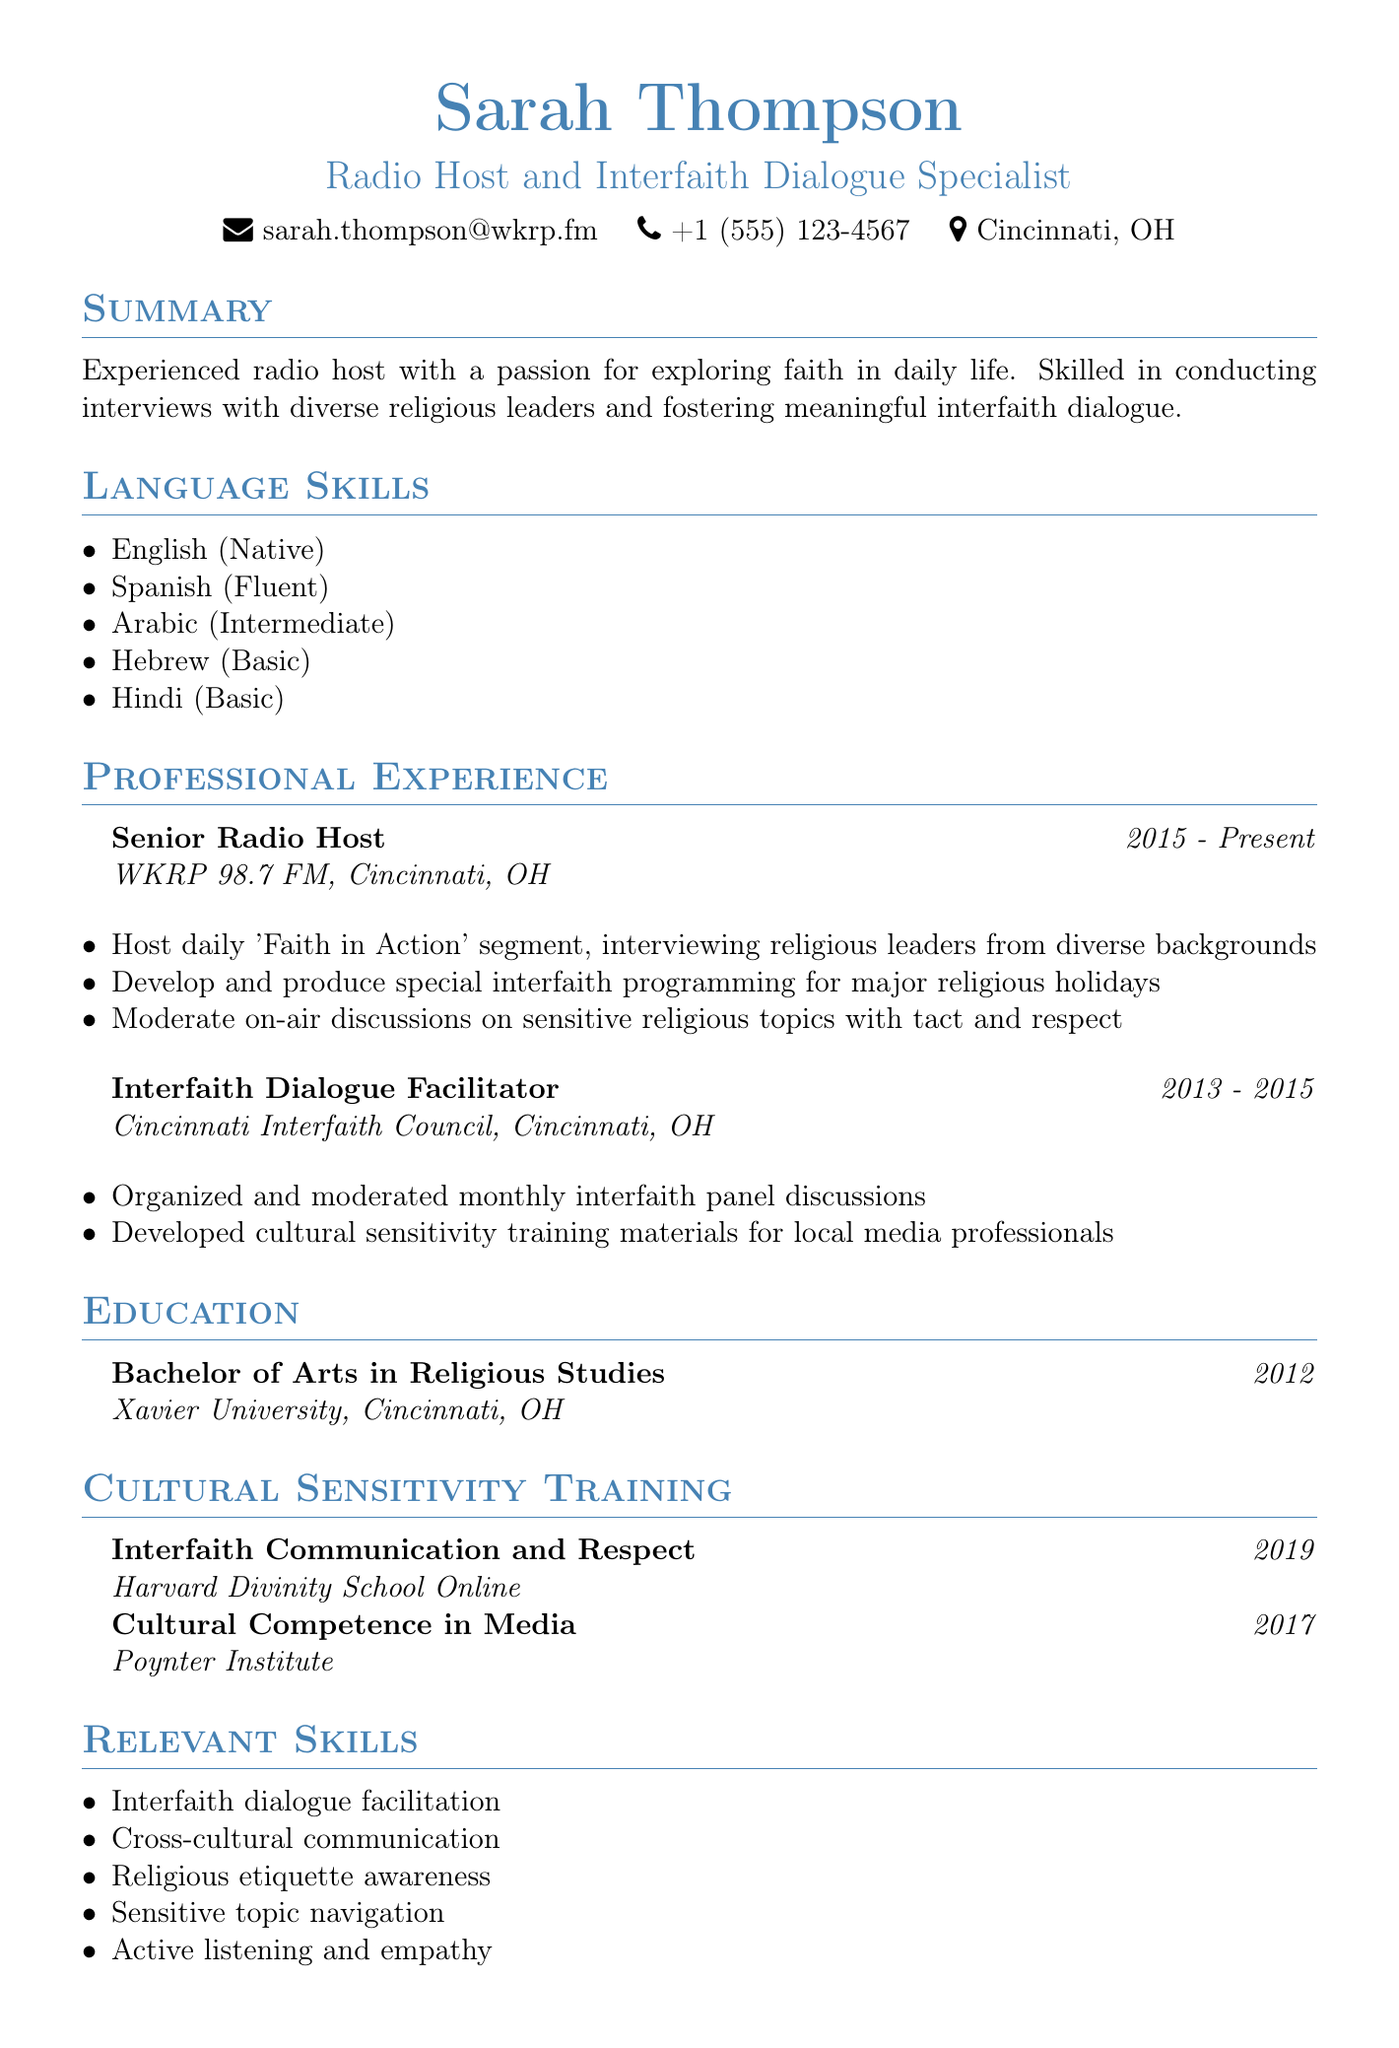What is the name of the radio host? The document states the name of the radio host as Sarah Thompson.
Answer: Sarah Thompson What is the email address of Sarah Thompson? The contact information in the document provides the email address as listed.
Answer: sarah.thompson@wkrp.fm What organization does Sarah Thompson currently work for? The professional experience section mentions her current employer.
Answer: WKRP 98.7 FM In which year did Sarah Thompson complete her Bachelor of Arts in Religious Studies? The education section indicates the year she graduated.
Answer: 2012 What language does Sarah Thompson speak at an intermediate level? The language skills section lists the languages and their proficiency levels.
Answer: Arabic Which course did Sarah Thompson complete in 2019? The cultural sensitivity training section specifies the courses and their years.
Answer: Interfaith Communication and Respect How long did Sarah Thompson work for the Cincinnati Interfaith Council? The professional experience section provides her employment duration at that organization.
Answer: 2013 - 2015 What skill is specifically mentioned related to conducting interviews? The relevant skills section outlines her abilities in relation to her role.
Answer: Active listening and empathy What type of training materials did Sarah develop for local media professionals? The responsibilities in her previous role highlight her work in this area.
Answer: Cultural sensitivity training materials 